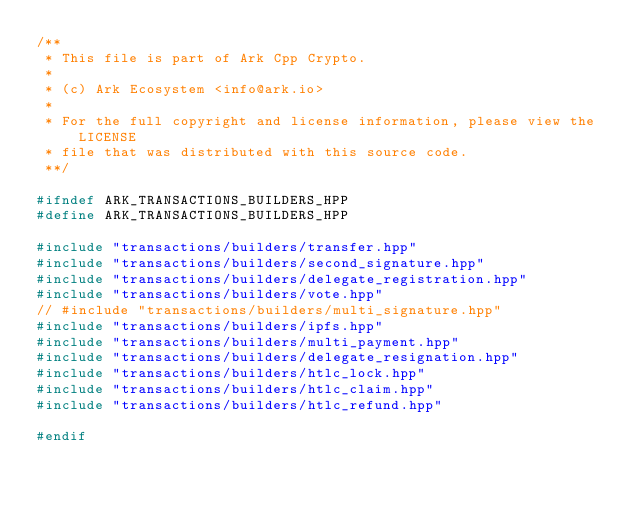Convert code to text. <code><loc_0><loc_0><loc_500><loc_500><_C++_>/**
 * This file is part of Ark Cpp Crypto.
 *
 * (c) Ark Ecosystem <info@ark.io>
 *
 * For the full copyright and license information, please view the LICENSE
 * file that was distributed with this source code.
 **/

#ifndef ARK_TRANSACTIONS_BUILDERS_HPP
#define ARK_TRANSACTIONS_BUILDERS_HPP

#include "transactions/builders/transfer.hpp"
#include "transactions/builders/second_signature.hpp"
#include "transactions/builders/delegate_registration.hpp"
#include "transactions/builders/vote.hpp"
// #include "transactions/builders/multi_signature.hpp"
#include "transactions/builders/ipfs.hpp"
#include "transactions/builders/multi_payment.hpp"
#include "transactions/builders/delegate_resignation.hpp"
#include "transactions/builders/htlc_lock.hpp"
#include "transactions/builders/htlc_claim.hpp"
#include "transactions/builders/htlc_refund.hpp"

#endif
</code> 